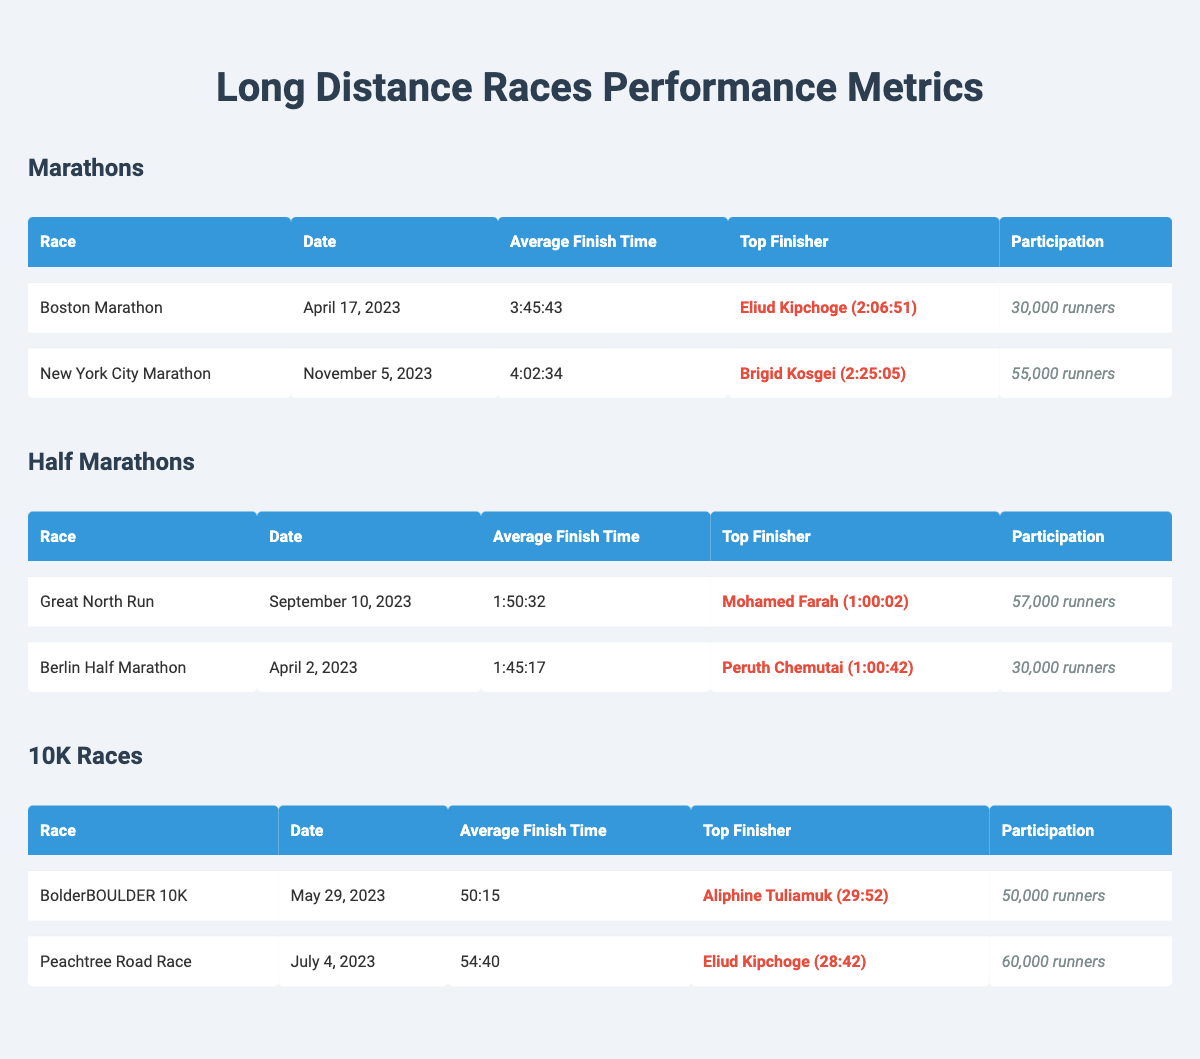What is the participation number for the New York City Marathon? The table states that the participation for the New York City Marathon is 55,000 runners.
Answer: 55,000 runners Who finished first in the Berlin Half Marathon? The table indicates that the top finisher for the Berlin Half Marathon is Peruth Chemutai.
Answer: Peruth Chemutai What is the average finish time for the Great North Run? The table shows that the average finish time for the Great North Run is 1:50:32.
Answer: 1:50:32 Which race had the highest number of participants? The New York City Marathon had 55,000 participants, while the Great North Run had 57,000 participants, making the Great North Run the highest.
Answer: Great North Run What is the difference between the average finish times of the Boston Marathon and the New York City Marathon? The average finish time for the Boston Marathon is 3:45:43, while for the New York City Marathon, it is 4:02:34. To find the difference, we convert the times into seconds and calculate. Boston: 3 hours, 45 minutes, 43 seconds = 13,543 seconds. New York: 4 hours, 2 minutes, 34 seconds = 14,553 seconds. The difference is 14,553 - 13,543 = 1,010 seconds or approximately 16 minutes and 50 seconds.
Answer: 16 minutes and 50 seconds Is it true that Eliud Kipchoge was the top finisher in both the Boston Marathon and the Peachtree Road Race? The table shows that Eliud Kipchoge was the top finisher in the Boston Marathon but not in the Peachtree Road Race; there, he finished first. Therefore, it is false.
Answer: No 